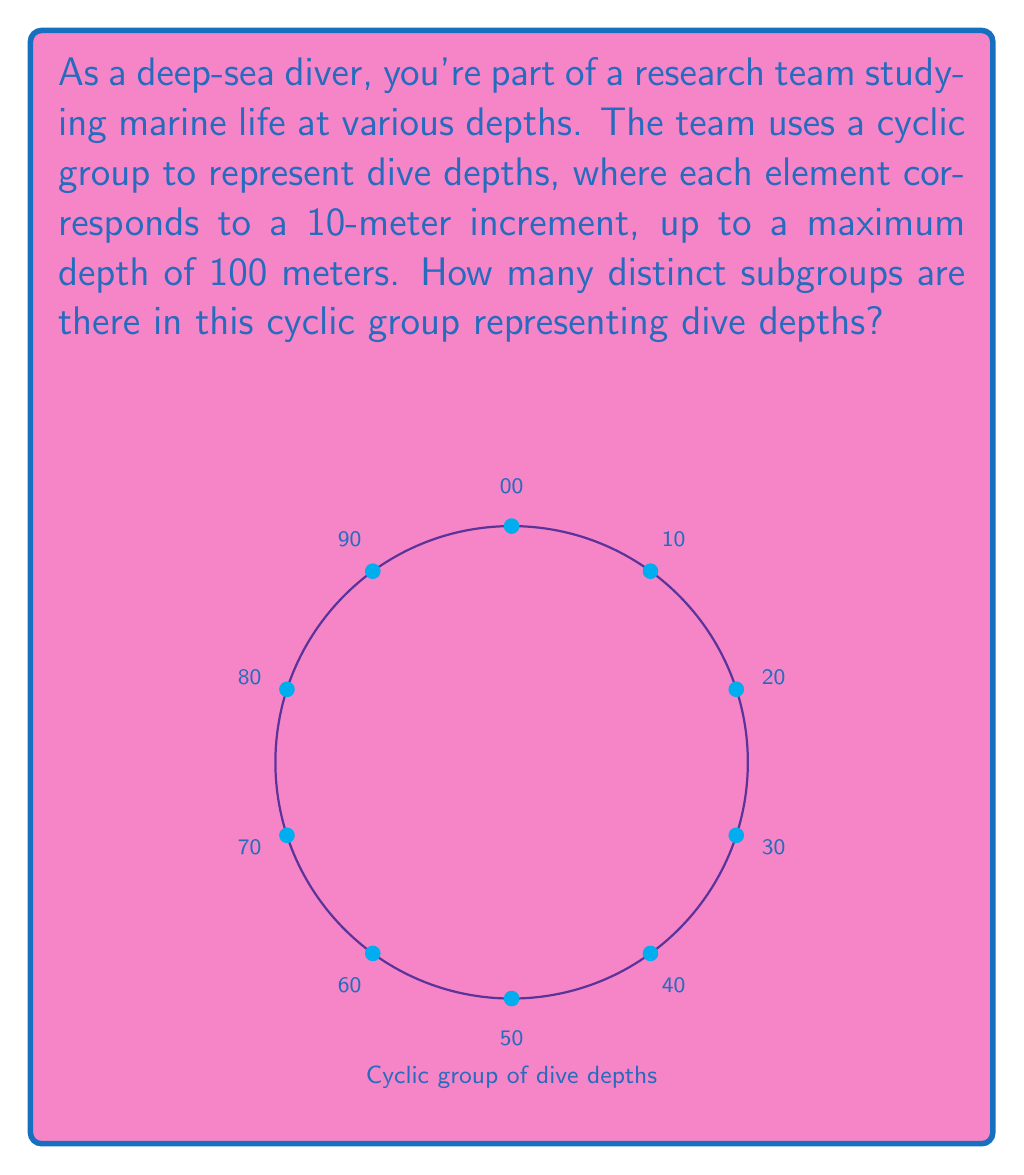Show me your answer to this math problem. Let's approach this step-by-step:

1) First, we need to identify the cyclic group. In this case, it's a cyclic group of order 10, which we can denote as $C_{10}$ or $\mathbb{Z}_{10}$.

2) In a cyclic group, the number of distinct subgroups is equal to the number of divisors of the group's order. This is because each subgroup of a cyclic group is also cyclic, and its order must divide the order of the main group.

3) The order of our group is 10. So, we need to find the divisors of 10.

4) The divisors of 10 are: 1, 2, 5, and 10.

5) Therefore, there are 4 distinct subgroups:
   - The trivial subgroup $\{0\}$ (corresponding to the surface)
   - A subgroup of order 2: $\{0, 50\}$ (surface and 50m depth)
   - A subgroup of order 5: $\{0, 20, 40, 60, 80\}$ (depths at 20m intervals)
   - The entire group $C_{10}$ (all depths from 0 to 90m in 10m intervals)

6) Each of these subgroups represents a set of depths at which the diver might collect samples or make observations.

Thus, there are 4 distinct subgroups in this cyclic group representing dive depths.
Answer: 4 